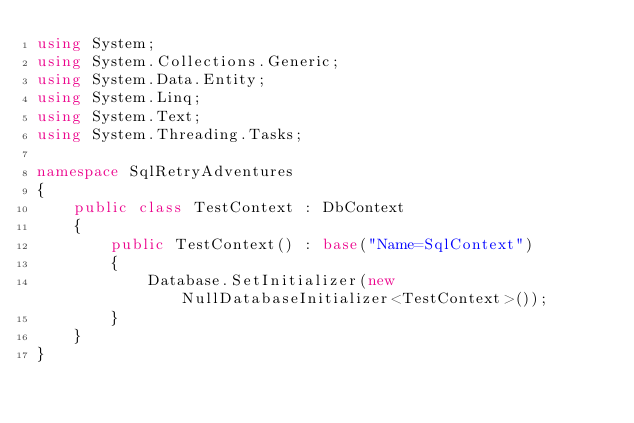<code> <loc_0><loc_0><loc_500><loc_500><_C#_>using System;
using System.Collections.Generic;
using System.Data.Entity;
using System.Linq;
using System.Text;
using System.Threading.Tasks;

namespace SqlRetryAdventures
{
    public class TestContext : DbContext
    {
        public TestContext() : base("Name=SqlContext")
        {
            Database.SetInitializer(new NullDatabaseInitializer<TestContext>());
        }
    }
}
</code> 